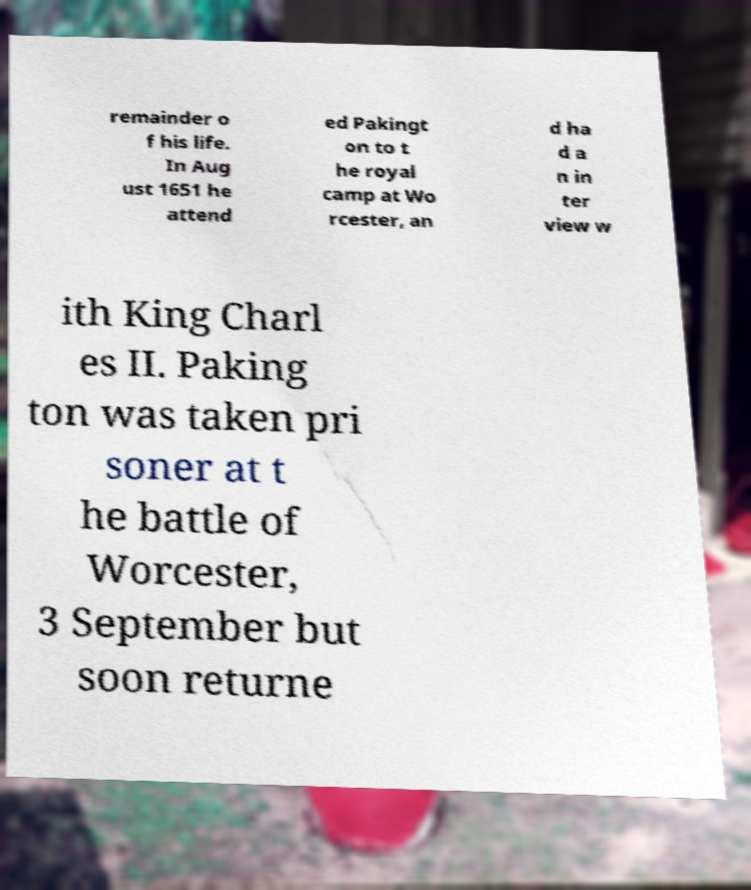What messages or text are displayed in this image? I need them in a readable, typed format. remainder o f his life. In Aug ust 1651 he attend ed Pakingt on to t he royal camp at Wo rcester, an d ha d a n in ter view w ith King Charl es II. Paking ton was taken pri soner at t he battle of Worcester, 3 September but soon returne 